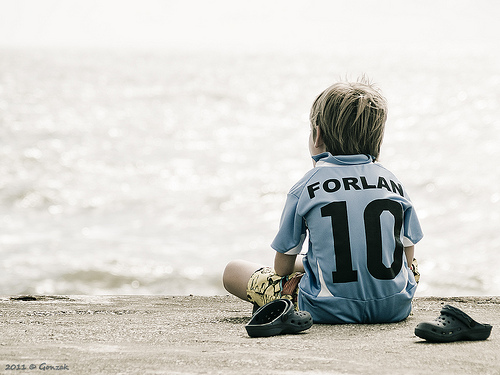<image>
Can you confirm if the number is on the shirt? Yes. Looking at the image, I can see the number is positioned on top of the shirt, with the shirt providing support. 